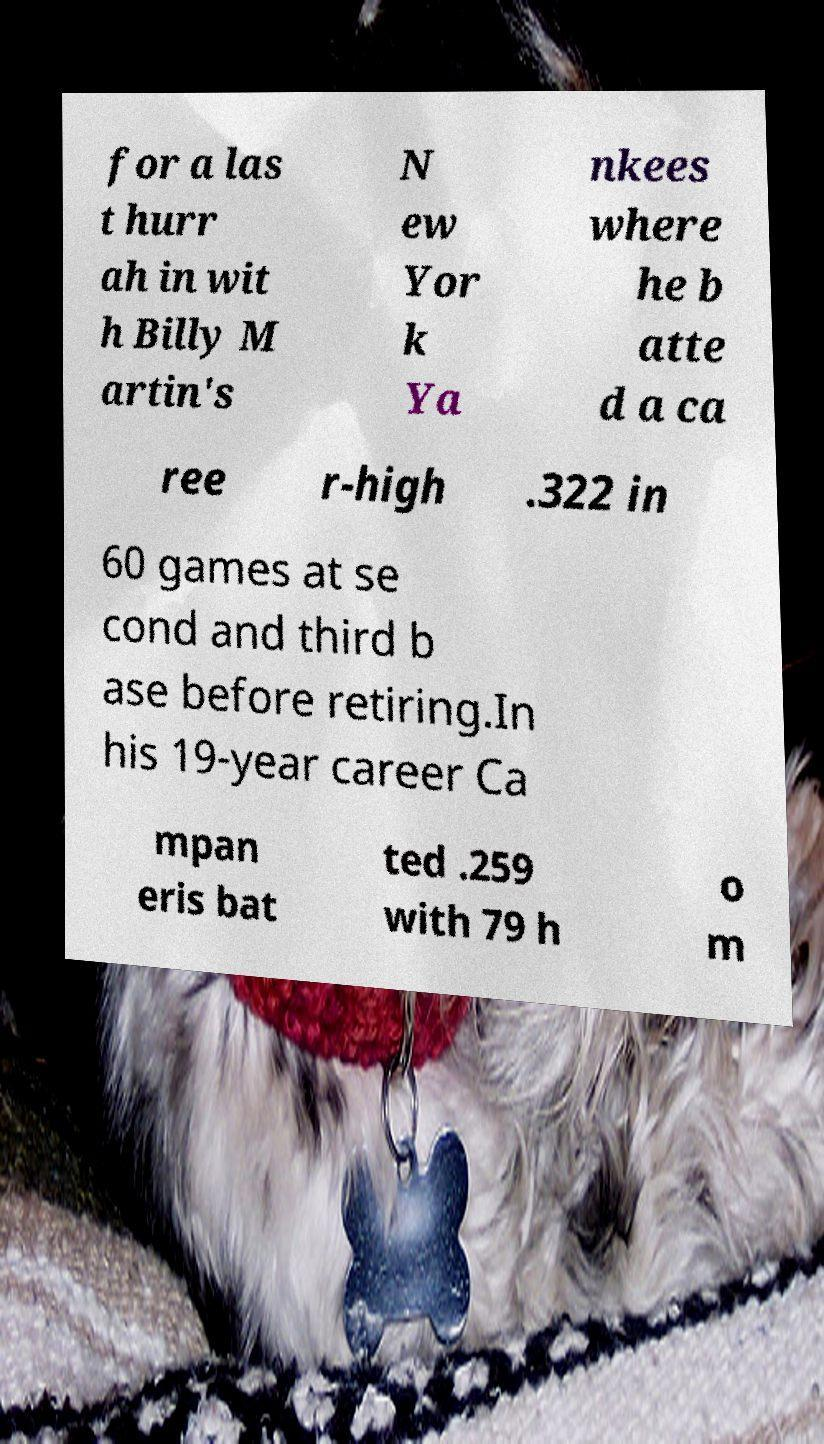There's text embedded in this image that I need extracted. Can you transcribe it verbatim? for a las t hurr ah in wit h Billy M artin's N ew Yor k Ya nkees where he b atte d a ca ree r-high .322 in 60 games at se cond and third b ase before retiring.In his 19-year career Ca mpan eris bat ted .259 with 79 h o m 